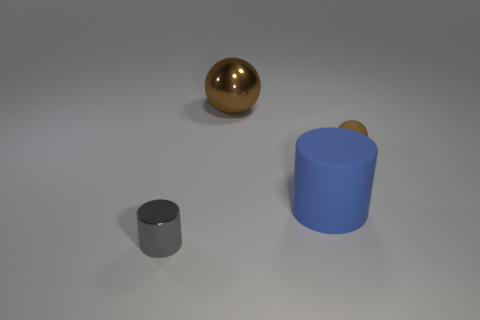There is a thing that is on the left side of the large blue rubber cylinder and in front of the large brown shiny sphere; what is it made of?
Give a very brief answer. Metal. What is the shape of the thing that is in front of the small rubber ball and to the right of the large brown metal ball?
Your response must be concise. Cylinder. The big ball that is made of the same material as the gray cylinder is what color?
Your response must be concise. Brown. How many blue things are made of the same material as the small brown thing?
Provide a succinct answer. 1. What material is the big ball that is the same color as the tiny rubber object?
Your answer should be compact. Metal. Is there a large matte object that has the same shape as the gray shiny thing?
Provide a short and direct response. Yes. Do the brown thing on the left side of the big blue cylinder and the big object that is on the right side of the big shiny object have the same material?
Your answer should be very brief. No. There is a brown sphere that is behind the small thing on the right side of the small thing in front of the blue cylinder; how big is it?
Provide a succinct answer. Large. There is another thing that is the same size as the blue matte object; what material is it?
Ensure brevity in your answer.  Metal. Is there another green metallic ball of the same size as the metallic sphere?
Offer a terse response. No. 